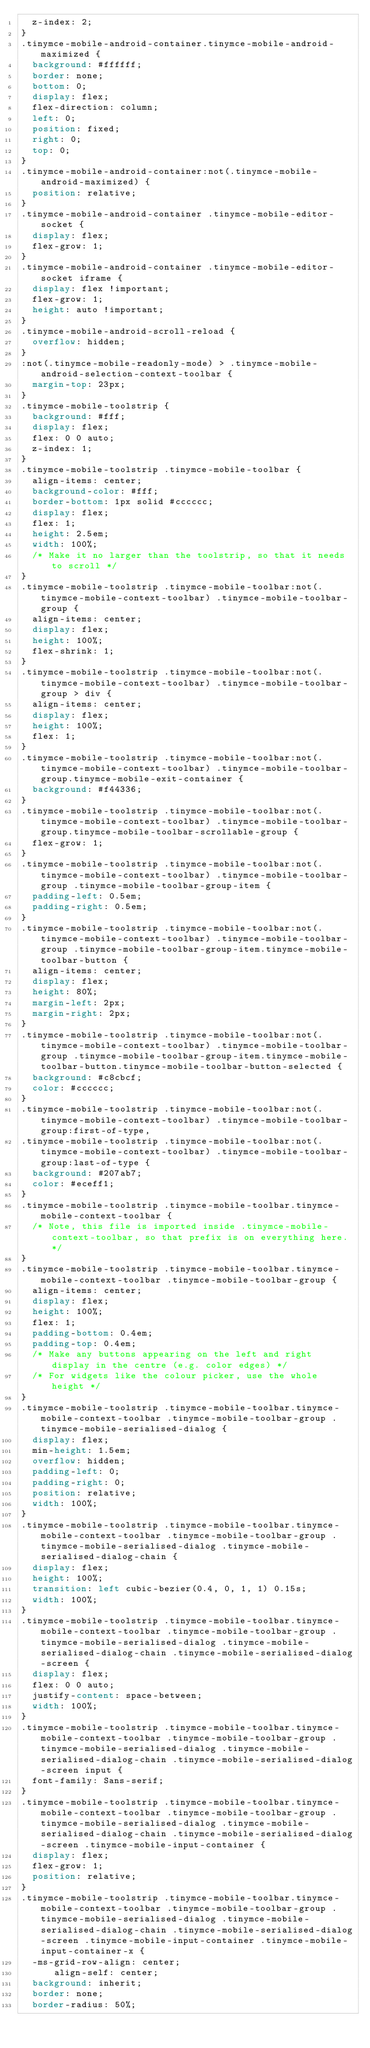<code> <loc_0><loc_0><loc_500><loc_500><_CSS_>  z-index: 2;
}
.tinymce-mobile-android-container.tinymce-mobile-android-maximized {
  background: #ffffff;
  border: none;
  bottom: 0;
  display: flex;
  flex-direction: column;
  left: 0;
  position: fixed;
  right: 0;
  top: 0;
}
.tinymce-mobile-android-container:not(.tinymce-mobile-android-maximized) {
  position: relative;
}
.tinymce-mobile-android-container .tinymce-mobile-editor-socket {
  display: flex;
  flex-grow: 1;
}
.tinymce-mobile-android-container .tinymce-mobile-editor-socket iframe {
  display: flex !important;
  flex-grow: 1;
  height: auto !important;
}
.tinymce-mobile-android-scroll-reload {
  overflow: hidden;
}
:not(.tinymce-mobile-readonly-mode) > .tinymce-mobile-android-selection-context-toolbar {
  margin-top: 23px;
}
.tinymce-mobile-toolstrip {
  background: #fff;
  display: flex;
  flex: 0 0 auto;
  z-index: 1;
}
.tinymce-mobile-toolstrip .tinymce-mobile-toolbar {
  align-items: center;
  background-color: #fff;
  border-bottom: 1px solid #cccccc;
  display: flex;
  flex: 1;
  height: 2.5em;
  width: 100%;
  /* Make it no larger than the toolstrip, so that it needs to scroll */
}
.tinymce-mobile-toolstrip .tinymce-mobile-toolbar:not(.tinymce-mobile-context-toolbar) .tinymce-mobile-toolbar-group {
  align-items: center;
  display: flex;
  height: 100%;
  flex-shrink: 1;
}
.tinymce-mobile-toolstrip .tinymce-mobile-toolbar:not(.tinymce-mobile-context-toolbar) .tinymce-mobile-toolbar-group > div {
  align-items: center;
  display: flex;
  height: 100%;
  flex: 1;
}
.tinymce-mobile-toolstrip .tinymce-mobile-toolbar:not(.tinymce-mobile-context-toolbar) .tinymce-mobile-toolbar-group.tinymce-mobile-exit-container {
  background: #f44336;
}
.tinymce-mobile-toolstrip .tinymce-mobile-toolbar:not(.tinymce-mobile-context-toolbar) .tinymce-mobile-toolbar-group.tinymce-mobile-toolbar-scrollable-group {
  flex-grow: 1;
}
.tinymce-mobile-toolstrip .tinymce-mobile-toolbar:not(.tinymce-mobile-context-toolbar) .tinymce-mobile-toolbar-group .tinymce-mobile-toolbar-group-item {
  padding-left: 0.5em;
  padding-right: 0.5em;
}
.tinymce-mobile-toolstrip .tinymce-mobile-toolbar:not(.tinymce-mobile-context-toolbar) .tinymce-mobile-toolbar-group .tinymce-mobile-toolbar-group-item.tinymce-mobile-toolbar-button {
  align-items: center;
  display: flex;
  height: 80%;
  margin-left: 2px;
  margin-right: 2px;
}
.tinymce-mobile-toolstrip .tinymce-mobile-toolbar:not(.tinymce-mobile-context-toolbar) .tinymce-mobile-toolbar-group .tinymce-mobile-toolbar-group-item.tinymce-mobile-toolbar-button.tinymce-mobile-toolbar-button-selected {
  background: #c8cbcf;
  color: #cccccc;
}
.tinymce-mobile-toolstrip .tinymce-mobile-toolbar:not(.tinymce-mobile-context-toolbar) .tinymce-mobile-toolbar-group:first-of-type,
.tinymce-mobile-toolstrip .tinymce-mobile-toolbar:not(.tinymce-mobile-context-toolbar) .tinymce-mobile-toolbar-group:last-of-type {
  background: #207ab7;
  color: #eceff1;
}
.tinymce-mobile-toolstrip .tinymce-mobile-toolbar.tinymce-mobile-context-toolbar {
  /* Note, this file is imported inside .tinymce-mobile-context-toolbar, so that prefix is on everything here. */
}
.tinymce-mobile-toolstrip .tinymce-mobile-toolbar.tinymce-mobile-context-toolbar .tinymce-mobile-toolbar-group {
  align-items: center;
  display: flex;
  height: 100%;
  flex: 1;
  padding-bottom: 0.4em;
  padding-top: 0.4em;
  /* Make any buttons appearing on the left and right display in the centre (e.g. color edges) */
  /* For widgets like the colour picker, use the whole height */
}
.tinymce-mobile-toolstrip .tinymce-mobile-toolbar.tinymce-mobile-context-toolbar .tinymce-mobile-toolbar-group .tinymce-mobile-serialised-dialog {
  display: flex;
  min-height: 1.5em;
  overflow: hidden;
  padding-left: 0;
  padding-right: 0;
  position: relative;
  width: 100%;
}
.tinymce-mobile-toolstrip .tinymce-mobile-toolbar.tinymce-mobile-context-toolbar .tinymce-mobile-toolbar-group .tinymce-mobile-serialised-dialog .tinymce-mobile-serialised-dialog-chain {
  display: flex;
  height: 100%;
  transition: left cubic-bezier(0.4, 0, 1, 1) 0.15s;
  width: 100%;
}
.tinymce-mobile-toolstrip .tinymce-mobile-toolbar.tinymce-mobile-context-toolbar .tinymce-mobile-toolbar-group .tinymce-mobile-serialised-dialog .tinymce-mobile-serialised-dialog-chain .tinymce-mobile-serialised-dialog-screen {
  display: flex;
  flex: 0 0 auto;
  justify-content: space-between;
  width: 100%;
}
.tinymce-mobile-toolstrip .tinymce-mobile-toolbar.tinymce-mobile-context-toolbar .tinymce-mobile-toolbar-group .tinymce-mobile-serialised-dialog .tinymce-mobile-serialised-dialog-chain .tinymce-mobile-serialised-dialog-screen input {
  font-family: Sans-serif;
}
.tinymce-mobile-toolstrip .tinymce-mobile-toolbar.tinymce-mobile-context-toolbar .tinymce-mobile-toolbar-group .tinymce-mobile-serialised-dialog .tinymce-mobile-serialised-dialog-chain .tinymce-mobile-serialised-dialog-screen .tinymce-mobile-input-container {
  display: flex;
  flex-grow: 1;
  position: relative;
}
.tinymce-mobile-toolstrip .tinymce-mobile-toolbar.tinymce-mobile-context-toolbar .tinymce-mobile-toolbar-group .tinymce-mobile-serialised-dialog .tinymce-mobile-serialised-dialog-chain .tinymce-mobile-serialised-dialog-screen .tinymce-mobile-input-container .tinymce-mobile-input-container-x {
  -ms-grid-row-align: center;
      align-self: center;
  background: inherit;
  border: none;
  border-radius: 50%;</code> 